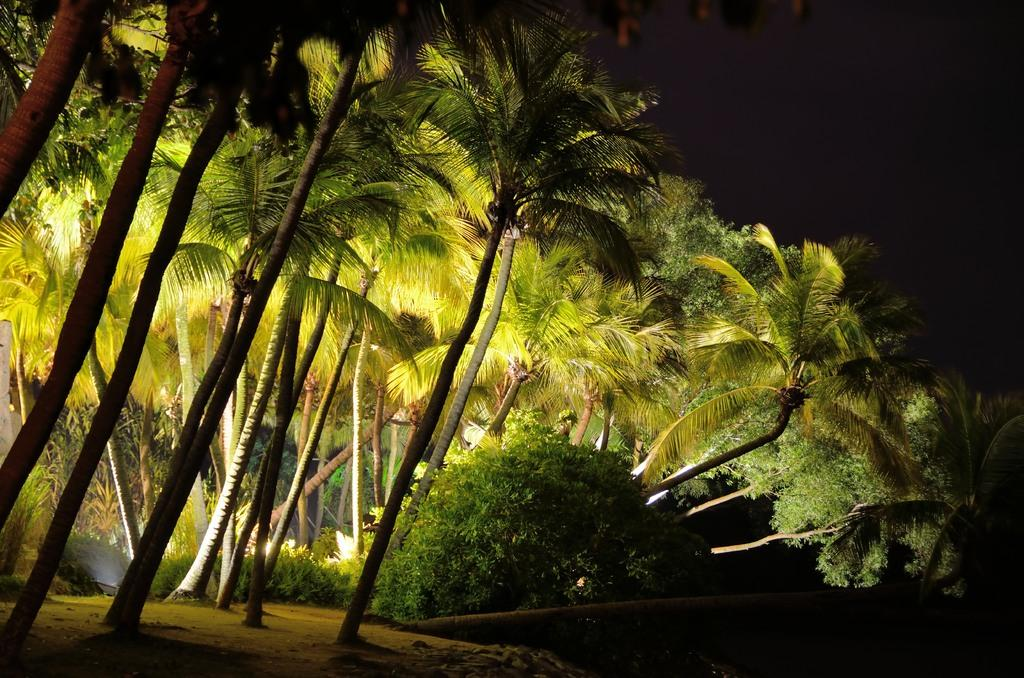What type of natural scenery can be seen in the background of the image? There are trees in the background of the image. What part of the image represents the ground? The ground is visible at the bottom of the image. What part of the image represents the sky? The sky is visible at the top of the image. What type of haircut is the tree on the left side of the image getting? There is no tree getting a haircut in the image, as trees do not receive haircuts. How does the crayon start the drawing process in the image? There is no crayon or drawing process present in the image. 